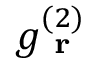<formula> <loc_0><loc_0><loc_500><loc_500>g _ { r } ^ { ( 2 ) }</formula> 